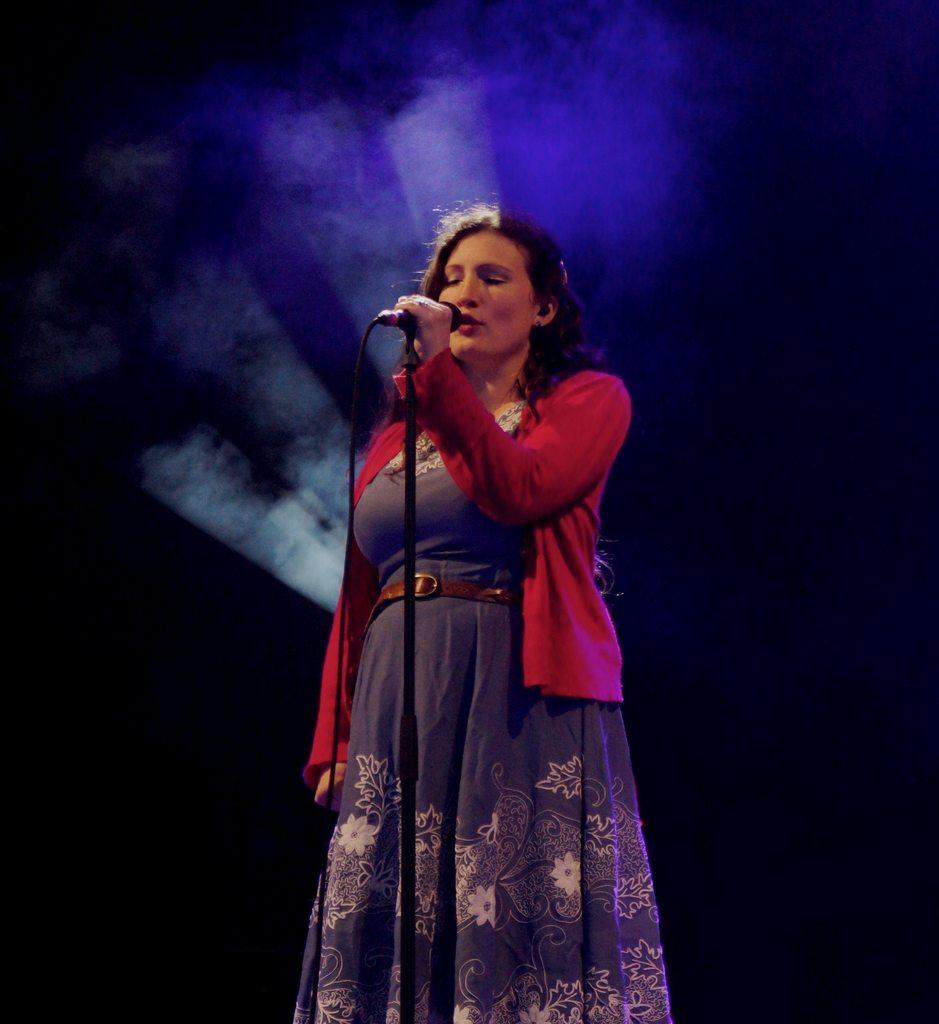What is the main subject in the foreground of the picture? There is a woman in the foreground of the picture. What is the woman doing in the image? The woman is singing. What is the woman holding while singing? The woman is holding a microphone. Can you describe any other objects or features in the image? There is a cable visible in the image, as well as a stand. Additionally, there is light and smoke in the background of the image. What type of appliance is the woman using to generate her ideas while singing? There is no appliance present in the image related to generating ideas. 